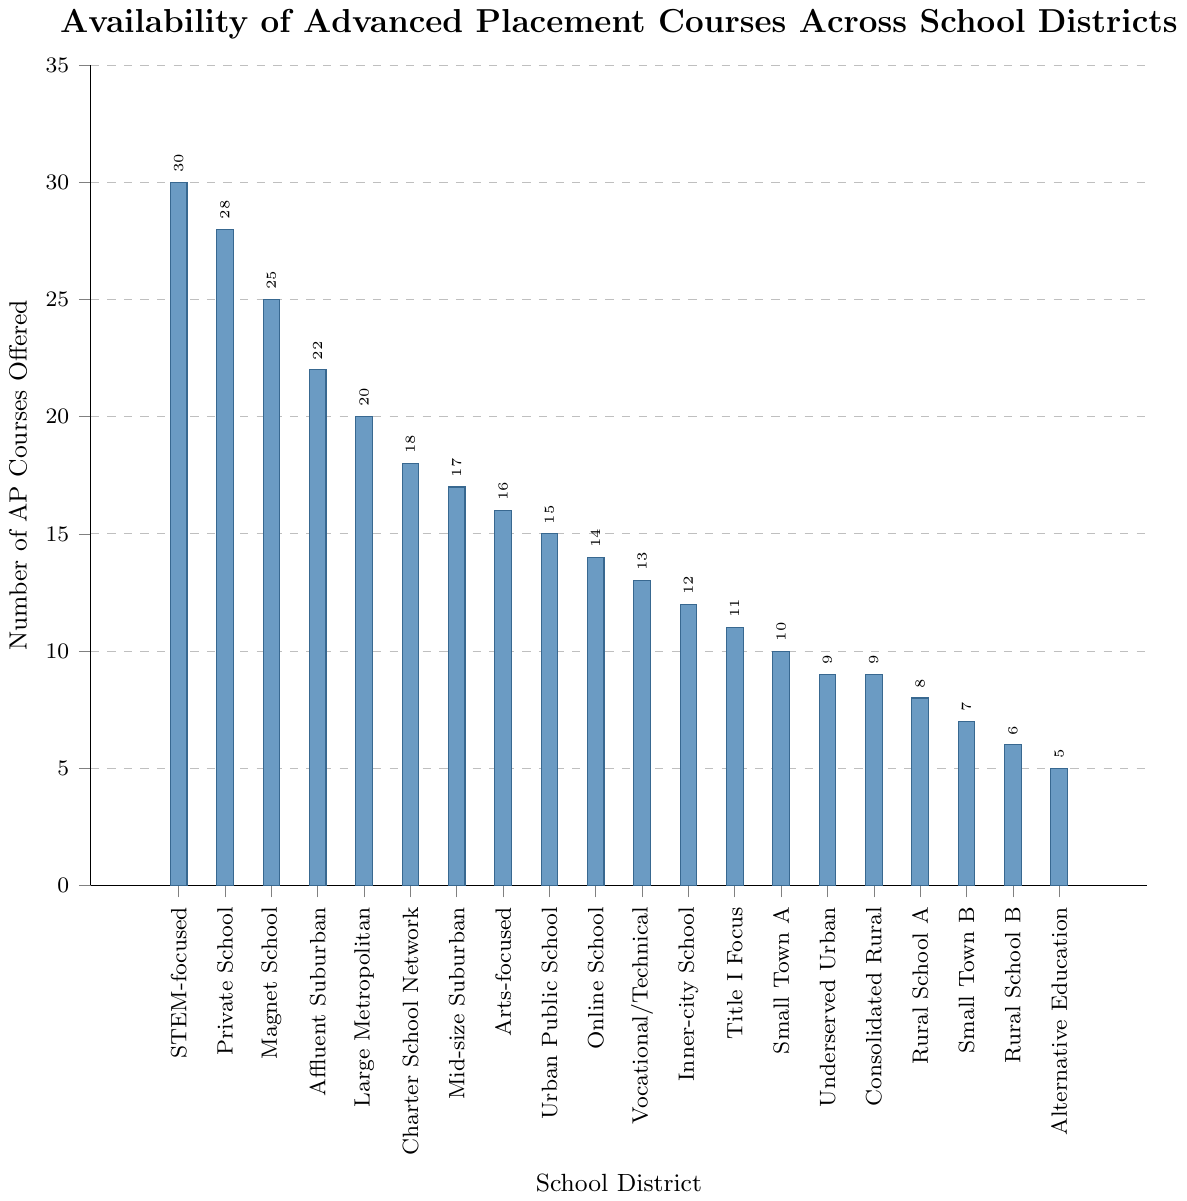What's the highest number of AP courses offered? The figure shows the number of AP courses offered by different school districts, with the tallest bar representing the school district with the most courses. To find the highest number, look for the tallest bar.
Answer: 30 How many AP courses are offered by the Online School District? Locate the bar labeled "Online School" and check the height of the bar, which corresponds to the number of AP courses offered.
Answer: 14 Which district offers more AP courses: Urban Public School District or Inner-city School District? Compare the heights of the bars labeled "Urban Public School" and "Inner-city School" to see which one is taller.
Answer: Urban Public School District How many districts offer more than 20 AP courses? Count the number of bars that have a height indicating more than 20 AP courses.
Answer: 4 Which district offers the fewest number of AP courses? Identify the smallest bar on the chart, which corresponds to the district with the fewest AP courses.
Answer: Alternative Education District What is the total number of AP courses offered by Affluent Suburban District and Large Metropolitan District? Find the height of the bars for Affluent Suburban District (22) and Large Metropolitan District (20) and sum them up.
Answer: 42 What is the average number of AP courses offered across all districts? Sum the number of AP courses offered by all districts and divide by the total number of districts (20). The sum is 310 (30 + 28 + 25 + 22 + 20 + 18 + 17 + 16 + 15 + 14 + 13 + 12 + 11 + 10 + 9 + 9 + 8 + 7 + 6 + 5). The average is 310/20.
Answer: 15.5 How many more AP courses does the Private School District offer compared to the Small Town District B? Find the difference between the number of AP courses offered by Private School District (28) and Small Town District B (7).
Answer: 21 Which has more AP courses: Magnet School District or Charter School Network? Compare the heights of the bars for Magnet School District and Charter School Network. Magnet School District is taller.
Answer: Magnet School District What is the difference in the number of AP courses offered between the Mid-size Suburban District and Title I Focus District? Subtract the number of AP courses offered by Title I Focus District (11) from that offered by Mid-size Suburban District (17).
Answer: 6 